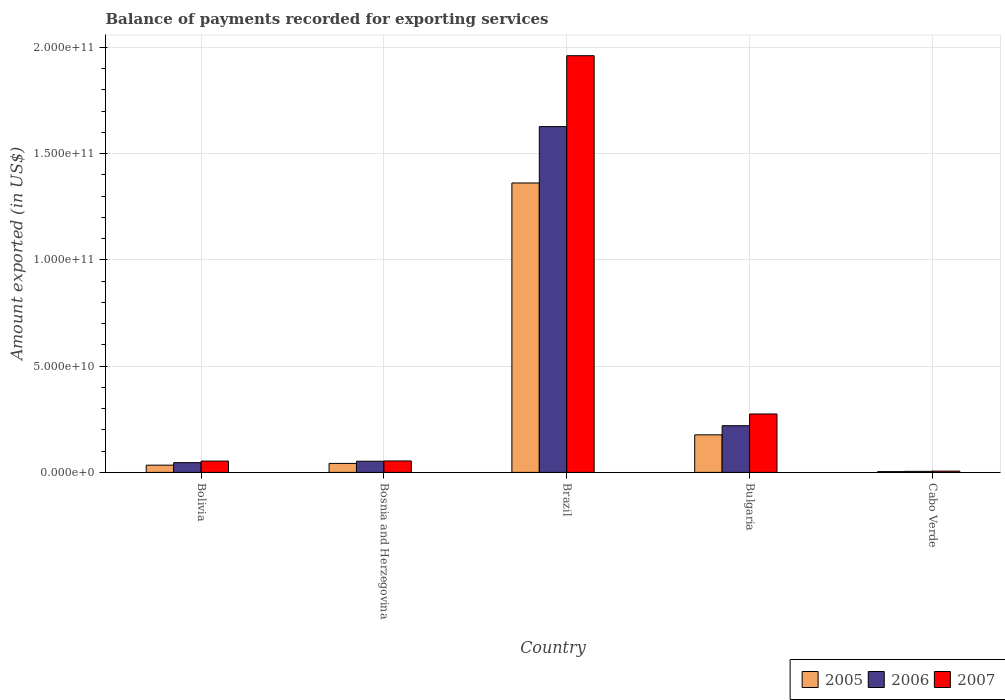Are the number of bars per tick equal to the number of legend labels?
Provide a short and direct response. Yes. Are the number of bars on each tick of the X-axis equal?
Provide a short and direct response. Yes. How many bars are there on the 5th tick from the left?
Provide a succinct answer. 3. What is the label of the 2nd group of bars from the left?
Your response must be concise. Bosnia and Herzegovina. What is the amount exported in 2005 in Cabo Verde?
Provide a succinct answer. 3.73e+08. Across all countries, what is the maximum amount exported in 2006?
Offer a very short reply. 1.63e+11. Across all countries, what is the minimum amount exported in 2005?
Your response must be concise. 3.73e+08. In which country was the amount exported in 2006 maximum?
Keep it short and to the point. Brazil. In which country was the amount exported in 2006 minimum?
Keep it short and to the point. Cabo Verde. What is the total amount exported in 2007 in the graph?
Offer a very short reply. 2.35e+11. What is the difference between the amount exported in 2007 in Bolivia and that in Brazil?
Keep it short and to the point. -1.91e+11. What is the difference between the amount exported in 2007 in Brazil and the amount exported in 2006 in Bulgaria?
Your response must be concise. 1.74e+11. What is the average amount exported in 2006 per country?
Offer a terse response. 3.90e+1. What is the difference between the amount exported of/in 2007 and amount exported of/in 2005 in Cabo Verde?
Your answer should be compact. 2.20e+08. In how many countries, is the amount exported in 2005 greater than 180000000000 US$?
Give a very brief answer. 0. What is the ratio of the amount exported in 2005 in Brazil to that in Bulgaria?
Offer a very short reply. 7.71. Is the amount exported in 2007 in Bolivia less than that in Brazil?
Give a very brief answer. Yes. Is the difference between the amount exported in 2007 in Bosnia and Herzegovina and Cabo Verde greater than the difference between the amount exported in 2005 in Bosnia and Herzegovina and Cabo Verde?
Your response must be concise. Yes. What is the difference between the highest and the second highest amount exported in 2005?
Your answer should be compact. 1.34e+1. What is the difference between the highest and the lowest amount exported in 2005?
Provide a succinct answer. 1.36e+11. Is the sum of the amount exported in 2007 in Bulgaria and Cabo Verde greater than the maximum amount exported in 2005 across all countries?
Your response must be concise. No. What does the 3rd bar from the right in Bulgaria represents?
Offer a very short reply. 2005. Is it the case that in every country, the sum of the amount exported in 2007 and amount exported in 2006 is greater than the amount exported in 2005?
Give a very brief answer. Yes. How many countries are there in the graph?
Offer a terse response. 5. What is the difference between two consecutive major ticks on the Y-axis?
Provide a succinct answer. 5.00e+1. Are the values on the major ticks of Y-axis written in scientific E-notation?
Offer a terse response. Yes. Does the graph contain grids?
Ensure brevity in your answer.  Yes. Where does the legend appear in the graph?
Provide a succinct answer. Bottom right. How many legend labels are there?
Ensure brevity in your answer.  3. What is the title of the graph?
Offer a very short reply. Balance of payments recorded for exporting services. What is the label or title of the Y-axis?
Make the answer very short. Amount exported (in US$). What is the Amount exported (in US$) in 2005 in Bolivia?
Provide a succinct answer. 3.40e+09. What is the Amount exported (in US$) in 2006 in Bolivia?
Keep it short and to the point. 4.58e+09. What is the Amount exported (in US$) of 2007 in Bolivia?
Provide a short and direct response. 5.32e+09. What is the Amount exported (in US$) in 2005 in Bosnia and Herzegovina?
Provide a short and direct response. 4.23e+09. What is the Amount exported (in US$) of 2006 in Bosnia and Herzegovina?
Your response must be concise. 5.25e+09. What is the Amount exported (in US$) of 2007 in Bosnia and Herzegovina?
Give a very brief answer. 5.38e+09. What is the Amount exported (in US$) in 2005 in Brazil?
Offer a very short reply. 1.36e+11. What is the Amount exported (in US$) of 2006 in Brazil?
Make the answer very short. 1.63e+11. What is the Amount exported (in US$) in 2007 in Brazil?
Give a very brief answer. 1.96e+11. What is the Amount exported (in US$) in 2005 in Bulgaria?
Give a very brief answer. 1.77e+1. What is the Amount exported (in US$) in 2006 in Bulgaria?
Make the answer very short. 2.20e+1. What is the Amount exported (in US$) in 2007 in Bulgaria?
Provide a succinct answer. 2.75e+1. What is the Amount exported (in US$) in 2005 in Cabo Verde?
Offer a very short reply. 3.73e+08. What is the Amount exported (in US$) of 2006 in Cabo Verde?
Ensure brevity in your answer.  4.91e+08. What is the Amount exported (in US$) of 2007 in Cabo Verde?
Your response must be concise. 5.93e+08. Across all countries, what is the maximum Amount exported (in US$) of 2005?
Your response must be concise. 1.36e+11. Across all countries, what is the maximum Amount exported (in US$) in 2006?
Offer a very short reply. 1.63e+11. Across all countries, what is the maximum Amount exported (in US$) in 2007?
Keep it short and to the point. 1.96e+11. Across all countries, what is the minimum Amount exported (in US$) in 2005?
Provide a succinct answer. 3.73e+08. Across all countries, what is the minimum Amount exported (in US$) in 2006?
Your response must be concise. 4.91e+08. Across all countries, what is the minimum Amount exported (in US$) of 2007?
Provide a short and direct response. 5.93e+08. What is the total Amount exported (in US$) of 2005 in the graph?
Provide a short and direct response. 1.62e+11. What is the total Amount exported (in US$) in 2006 in the graph?
Make the answer very short. 1.95e+11. What is the total Amount exported (in US$) in 2007 in the graph?
Your response must be concise. 2.35e+11. What is the difference between the Amount exported (in US$) in 2005 in Bolivia and that in Bosnia and Herzegovina?
Make the answer very short. -8.26e+08. What is the difference between the Amount exported (in US$) in 2006 in Bolivia and that in Bosnia and Herzegovina?
Provide a short and direct response. -6.69e+08. What is the difference between the Amount exported (in US$) in 2007 in Bolivia and that in Bosnia and Herzegovina?
Ensure brevity in your answer.  -5.49e+07. What is the difference between the Amount exported (in US$) of 2005 in Bolivia and that in Brazil?
Keep it short and to the point. -1.33e+11. What is the difference between the Amount exported (in US$) in 2006 in Bolivia and that in Brazil?
Your answer should be very brief. -1.58e+11. What is the difference between the Amount exported (in US$) in 2007 in Bolivia and that in Brazil?
Offer a very short reply. -1.91e+11. What is the difference between the Amount exported (in US$) of 2005 in Bolivia and that in Bulgaria?
Offer a very short reply. -1.43e+1. What is the difference between the Amount exported (in US$) in 2006 in Bolivia and that in Bulgaria?
Your answer should be compact. -1.74e+1. What is the difference between the Amount exported (in US$) in 2007 in Bolivia and that in Bulgaria?
Your answer should be very brief. -2.22e+1. What is the difference between the Amount exported (in US$) of 2005 in Bolivia and that in Cabo Verde?
Offer a terse response. 3.03e+09. What is the difference between the Amount exported (in US$) of 2006 in Bolivia and that in Cabo Verde?
Your answer should be compact. 4.09e+09. What is the difference between the Amount exported (in US$) in 2007 in Bolivia and that in Cabo Verde?
Provide a short and direct response. 4.73e+09. What is the difference between the Amount exported (in US$) of 2005 in Bosnia and Herzegovina and that in Brazil?
Your answer should be compact. -1.32e+11. What is the difference between the Amount exported (in US$) in 2006 in Bosnia and Herzegovina and that in Brazil?
Provide a succinct answer. -1.57e+11. What is the difference between the Amount exported (in US$) of 2007 in Bosnia and Herzegovina and that in Brazil?
Ensure brevity in your answer.  -1.91e+11. What is the difference between the Amount exported (in US$) of 2005 in Bosnia and Herzegovina and that in Bulgaria?
Provide a succinct answer. -1.34e+1. What is the difference between the Amount exported (in US$) in 2006 in Bosnia and Herzegovina and that in Bulgaria?
Offer a very short reply. -1.67e+1. What is the difference between the Amount exported (in US$) in 2007 in Bosnia and Herzegovina and that in Bulgaria?
Your response must be concise. -2.21e+1. What is the difference between the Amount exported (in US$) of 2005 in Bosnia and Herzegovina and that in Cabo Verde?
Give a very brief answer. 3.85e+09. What is the difference between the Amount exported (in US$) in 2006 in Bosnia and Herzegovina and that in Cabo Verde?
Keep it short and to the point. 4.76e+09. What is the difference between the Amount exported (in US$) of 2007 in Bosnia and Herzegovina and that in Cabo Verde?
Your response must be concise. 4.79e+09. What is the difference between the Amount exported (in US$) in 2005 in Brazil and that in Bulgaria?
Give a very brief answer. 1.19e+11. What is the difference between the Amount exported (in US$) of 2006 in Brazil and that in Bulgaria?
Your answer should be very brief. 1.41e+11. What is the difference between the Amount exported (in US$) of 2007 in Brazil and that in Bulgaria?
Make the answer very short. 1.69e+11. What is the difference between the Amount exported (in US$) of 2005 in Brazil and that in Cabo Verde?
Provide a succinct answer. 1.36e+11. What is the difference between the Amount exported (in US$) of 2006 in Brazil and that in Cabo Verde?
Offer a terse response. 1.62e+11. What is the difference between the Amount exported (in US$) of 2007 in Brazil and that in Cabo Verde?
Ensure brevity in your answer.  1.96e+11. What is the difference between the Amount exported (in US$) in 2005 in Bulgaria and that in Cabo Verde?
Give a very brief answer. 1.73e+1. What is the difference between the Amount exported (in US$) of 2006 in Bulgaria and that in Cabo Verde?
Your answer should be very brief. 2.15e+1. What is the difference between the Amount exported (in US$) in 2007 in Bulgaria and that in Cabo Verde?
Offer a very short reply. 2.69e+1. What is the difference between the Amount exported (in US$) of 2005 in Bolivia and the Amount exported (in US$) of 2006 in Bosnia and Herzegovina?
Your answer should be very brief. -1.85e+09. What is the difference between the Amount exported (in US$) of 2005 in Bolivia and the Amount exported (in US$) of 2007 in Bosnia and Herzegovina?
Provide a short and direct response. -1.98e+09. What is the difference between the Amount exported (in US$) in 2006 in Bolivia and the Amount exported (in US$) in 2007 in Bosnia and Herzegovina?
Make the answer very short. -7.95e+08. What is the difference between the Amount exported (in US$) of 2005 in Bolivia and the Amount exported (in US$) of 2006 in Brazil?
Keep it short and to the point. -1.59e+11. What is the difference between the Amount exported (in US$) in 2005 in Bolivia and the Amount exported (in US$) in 2007 in Brazil?
Your response must be concise. -1.93e+11. What is the difference between the Amount exported (in US$) in 2006 in Bolivia and the Amount exported (in US$) in 2007 in Brazil?
Ensure brevity in your answer.  -1.92e+11. What is the difference between the Amount exported (in US$) of 2005 in Bolivia and the Amount exported (in US$) of 2006 in Bulgaria?
Make the answer very short. -1.86e+1. What is the difference between the Amount exported (in US$) of 2005 in Bolivia and the Amount exported (in US$) of 2007 in Bulgaria?
Your response must be concise. -2.41e+1. What is the difference between the Amount exported (in US$) in 2006 in Bolivia and the Amount exported (in US$) in 2007 in Bulgaria?
Offer a terse response. -2.29e+1. What is the difference between the Amount exported (in US$) in 2005 in Bolivia and the Amount exported (in US$) in 2006 in Cabo Verde?
Your answer should be compact. 2.91e+09. What is the difference between the Amount exported (in US$) in 2005 in Bolivia and the Amount exported (in US$) in 2007 in Cabo Verde?
Offer a very short reply. 2.81e+09. What is the difference between the Amount exported (in US$) in 2006 in Bolivia and the Amount exported (in US$) in 2007 in Cabo Verde?
Offer a very short reply. 3.99e+09. What is the difference between the Amount exported (in US$) in 2005 in Bosnia and Herzegovina and the Amount exported (in US$) in 2006 in Brazil?
Your response must be concise. -1.59e+11. What is the difference between the Amount exported (in US$) of 2005 in Bosnia and Herzegovina and the Amount exported (in US$) of 2007 in Brazil?
Provide a succinct answer. -1.92e+11. What is the difference between the Amount exported (in US$) of 2006 in Bosnia and Herzegovina and the Amount exported (in US$) of 2007 in Brazil?
Your answer should be very brief. -1.91e+11. What is the difference between the Amount exported (in US$) in 2005 in Bosnia and Herzegovina and the Amount exported (in US$) in 2006 in Bulgaria?
Make the answer very short. -1.77e+1. What is the difference between the Amount exported (in US$) of 2005 in Bosnia and Herzegovina and the Amount exported (in US$) of 2007 in Bulgaria?
Provide a short and direct response. -2.33e+1. What is the difference between the Amount exported (in US$) of 2006 in Bosnia and Herzegovina and the Amount exported (in US$) of 2007 in Bulgaria?
Make the answer very short. -2.22e+1. What is the difference between the Amount exported (in US$) in 2005 in Bosnia and Herzegovina and the Amount exported (in US$) in 2006 in Cabo Verde?
Ensure brevity in your answer.  3.74e+09. What is the difference between the Amount exported (in US$) of 2005 in Bosnia and Herzegovina and the Amount exported (in US$) of 2007 in Cabo Verde?
Offer a very short reply. 3.63e+09. What is the difference between the Amount exported (in US$) of 2006 in Bosnia and Herzegovina and the Amount exported (in US$) of 2007 in Cabo Verde?
Give a very brief answer. 4.66e+09. What is the difference between the Amount exported (in US$) in 2005 in Brazil and the Amount exported (in US$) in 2006 in Bulgaria?
Provide a short and direct response. 1.14e+11. What is the difference between the Amount exported (in US$) of 2005 in Brazil and the Amount exported (in US$) of 2007 in Bulgaria?
Make the answer very short. 1.09e+11. What is the difference between the Amount exported (in US$) in 2006 in Brazil and the Amount exported (in US$) in 2007 in Bulgaria?
Keep it short and to the point. 1.35e+11. What is the difference between the Amount exported (in US$) of 2005 in Brazil and the Amount exported (in US$) of 2006 in Cabo Verde?
Provide a short and direct response. 1.36e+11. What is the difference between the Amount exported (in US$) of 2005 in Brazil and the Amount exported (in US$) of 2007 in Cabo Verde?
Your response must be concise. 1.36e+11. What is the difference between the Amount exported (in US$) of 2006 in Brazil and the Amount exported (in US$) of 2007 in Cabo Verde?
Make the answer very short. 1.62e+11. What is the difference between the Amount exported (in US$) of 2005 in Bulgaria and the Amount exported (in US$) of 2006 in Cabo Verde?
Your answer should be compact. 1.72e+1. What is the difference between the Amount exported (in US$) of 2005 in Bulgaria and the Amount exported (in US$) of 2007 in Cabo Verde?
Provide a succinct answer. 1.71e+1. What is the difference between the Amount exported (in US$) of 2006 in Bulgaria and the Amount exported (in US$) of 2007 in Cabo Verde?
Give a very brief answer. 2.14e+1. What is the average Amount exported (in US$) of 2005 per country?
Offer a terse response. 3.24e+1. What is the average Amount exported (in US$) of 2006 per country?
Offer a very short reply. 3.90e+1. What is the average Amount exported (in US$) in 2007 per country?
Keep it short and to the point. 4.70e+1. What is the difference between the Amount exported (in US$) of 2005 and Amount exported (in US$) of 2006 in Bolivia?
Your response must be concise. -1.18e+09. What is the difference between the Amount exported (in US$) in 2005 and Amount exported (in US$) in 2007 in Bolivia?
Your response must be concise. -1.92e+09. What is the difference between the Amount exported (in US$) in 2006 and Amount exported (in US$) in 2007 in Bolivia?
Offer a very short reply. -7.40e+08. What is the difference between the Amount exported (in US$) in 2005 and Amount exported (in US$) in 2006 in Bosnia and Herzegovina?
Give a very brief answer. -1.03e+09. What is the difference between the Amount exported (in US$) of 2005 and Amount exported (in US$) of 2007 in Bosnia and Herzegovina?
Provide a short and direct response. -1.15e+09. What is the difference between the Amount exported (in US$) in 2006 and Amount exported (in US$) in 2007 in Bosnia and Herzegovina?
Provide a succinct answer. -1.26e+08. What is the difference between the Amount exported (in US$) of 2005 and Amount exported (in US$) of 2006 in Brazil?
Make the answer very short. -2.65e+1. What is the difference between the Amount exported (in US$) in 2005 and Amount exported (in US$) in 2007 in Brazil?
Offer a terse response. -5.99e+1. What is the difference between the Amount exported (in US$) in 2006 and Amount exported (in US$) in 2007 in Brazil?
Provide a short and direct response. -3.34e+1. What is the difference between the Amount exported (in US$) in 2005 and Amount exported (in US$) in 2006 in Bulgaria?
Give a very brief answer. -4.30e+09. What is the difference between the Amount exported (in US$) of 2005 and Amount exported (in US$) of 2007 in Bulgaria?
Offer a terse response. -9.81e+09. What is the difference between the Amount exported (in US$) of 2006 and Amount exported (in US$) of 2007 in Bulgaria?
Ensure brevity in your answer.  -5.52e+09. What is the difference between the Amount exported (in US$) of 2005 and Amount exported (in US$) of 2006 in Cabo Verde?
Provide a succinct answer. -1.18e+08. What is the difference between the Amount exported (in US$) of 2005 and Amount exported (in US$) of 2007 in Cabo Verde?
Give a very brief answer. -2.20e+08. What is the difference between the Amount exported (in US$) of 2006 and Amount exported (in US$) of 2007 in Cabo Verde?
Provide a short and direct response. -1.01e+08. What is the ratio of the Amount exported (in US$) in 2005 in Bolivia to that in Bosnia and Herzegovina?
Make the answer very short. 0.8. What is the ratio of the Amount exported (in US$) in 2006 in Bolivia to that in Bosnia and Herzegovina?
Give a very brief answer. 0.87. What is the ratio of the Amount exported (in US$) in 2007 in Bolivia to that in Bosnia and Herzegovina?
Keep it short and to the point. 0.99. What is the ratio of the Amount exported (in US$) of 2005 in Bolivia to that in Brazil?
Keep it short and to the point. 0.03. What is the ratio of the Amount exported (in US$) in 2006 in Bolivia to that in Brazil?
Your response must be concise. 0.03. What is the ratio of the Amount exported (in US$) in 2007 in Bolivia to that in Brazil?
Ensure brevity in your answer.  0.03. What is the ratio of the Amount exported (in US$) of 2005 in Bolivia to that in Bulgaria?
Offer a very short reply. 0.19. What is the ratio of the Amount exported (in US$) of 2006 in Bolivia to that in Bulgaria?
Give a very brief answer. 0.21. What is the ratio of the Amount exported (in US$) in 2007 in Bolivia to that in Bulgaria?
Provide a succinct answer. 0.19. What is the ratio of the Amount exported (in US$) of 2005 in Bolivia to that in Cabo Verde?
Your response must be concise. 9.12. What is the ratio of the Amount exported (in US$) of 2006 in Bolivia to that in Cabo Verde?
Your answer should be very brief. 9.33. What is the ratio of the Amount exported (in US$) of 2007 in Bolivia to that in Cabo Verde?
Your answer should be compact. 8.98. What is the ratio of the Amount exported (in US$) in 2005 in Bosnia and Herzegovina to that in Brazil?
Give a very brief answer. 0.03. What is the ratio of the Amount exported (in US$) of 2006 in Bosnia and Herzegovina to that in Brazil?
Ensure brevity in your answer.  0.03. What is the ratio of the Amount exported (in US$) in 2007 in Bosnia and Herzegovina to that in Brazil?
Give a very brief answer. 0.03. What is the ratio of the Amount exported (in US$) of 2005 in Bosnia and Herzegovina to that in Bulgaria?
Ensure brevity in your answer.  0.24. What is the ratio of the Amount exported (in US$) in 2006 in Bosnia and Herzegovina to that in Bulgaria?
Offer a terse response. 0.24. What is the ratio of the Amount exported (in US$) of 2007 in Bosnia and Herzegovina to that in Bulgaria?
Give a very brief answer. 0.2. What is the ratio of the Amount exported (in US$) of 2005 in Bosnia and Herzegovina to that in Cabo Verde?
Make the answer very short. 11.33. What is the ratio of the Amount exported (in US$) of 2006 in Bosnia and Herzegovina to that in Cabo Verde?
Provide a short and direct response. 10.69. What is the ratio of the Amount exported (in US$) in 2007 in Bosnia and Herzegovina to that in Cabo Verde?
Offer a very short reply. 9.08. What is the ratio of the Amount exported (in US$) in 2005 in Brazil to that in Bulgaria?
Keep it short and to the point. 7.71. What is the ratio of the Amount exported (in US$) of 2006 in Brazil to that in Bulgaria?
Provide a succinct answer. 7.41. What is the ratio of the Amount exported (in US$) in 2007 in Brazil to that in Bulgaria?
Offer a terse response. 7.13. What is the ratio of the Amount exported (in US$) of 2005 in Brazil to that in Cabo Verde?
Provide a short and direct response. 365.14. What is the ratio of the Amount exported (in US$) of 2006 in Brazil to that in Cabo Verde?
Your response must be concise. 331.2. What is the ratio of the Amount exported (in US$) in 2007 in Brazil to that in Cabo Verde?
Your answer should be very brief. 330.82. What is the ratio of the Amount exported (in US$) in 2005 in Bulgaria to that in Cabo Verde?
Ensure brevity in your answer.  47.38. What is the ratio of the Amount exported (in US$) in 2006 in Bulgaria to that in Cabo Verde?
Offer a very short reply. 44.72. What is the ratio of the Amount exported (in US$) in 2007 in Bulgaria to that in Cabo Verde?
Offer a very short reply. 46.37. What is the difference between the highest and the second highest Amount exported (in US$) of 2005?
Your answer should be compact. 1.19e+11. What is the difference between the highest and the second highest Amount exported (in US$) of 2006?
Give a very brief answer. 1.41e+11. What is the difference between the highest and the second highest Amount exported (in US$) of 2007?
Give a very brief answer. 1.69e+11. What is the difference between the highest and the lowest Amount exported (in US$) of 2005?
Offer a very short reply. 1.36e+11. What is the difference between the highest and the lowest Amount exported (in US$) in 2006?
Keep it short and to the point. 1.62e+11. What is the difference between the highest and the lowest Amount exported (in US$) in 2007?
Your answer should be compact. 1.96e+11. 